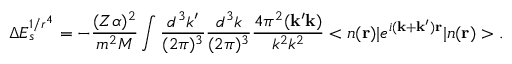<formula> <loc_0><loc_0><loc_500><loc_500>\Delta E _ { s } ^ { 1 / r ^ { 4 } } = - \frac { ( Z \alpha ) ^ { 2 } } { m ^ { 2 } M } \int \frac { d ^ { 3 } k ^ { \prime } } { ( 2 \pi ) ^ { 3 } } \frac { d ^ { 3 } k } { ( 2 \pi ) ^ { 3 } } \frac { 4 \pi ^ { 2 } ( { k ^ { \prime } k } ) } { k ^ { 2 } k ^ { 2 } } < n ( { r } ) | e ^ { i { ( k + k ^ { \prime } ) r } } | n ( { r } ) > .</formula> 